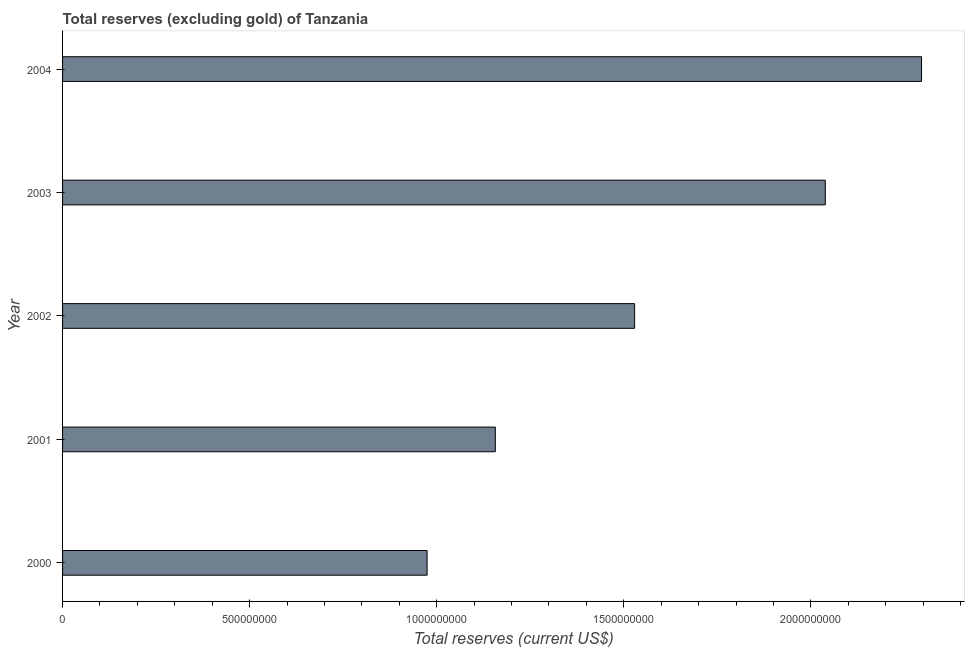What is the title of the graph?
Give a very brief answer. Total reserves (excluding gold) of Tanzania. What is the label or title of the X-axis?
Ensure brevity in your answer.  Total reserves (current US$). What is the label or title of the Y-axis?
Give a very brief answer. Year. What is the total reserves (excluding gold) in 2001?
Make the answer very short. 1.16e+09. Across all years, what is the maximum total reserves (excluding gold)?
Make the answer very short. 2.30e+09. Across all years, what is the minimum total reserves (excluding gold)?
Your answer should be compact. 9.74e+08. In which year was the total reserves (excluding gold) maximum?
Provide a succinct answer. 2004. What is the sum of the total reserves (excluding gold)?
Give a very brief answer. 7.99e+09. What is the difference between the total reserves (excluding gold) in 2001 and 2002?
Provide a short and direct response. -3.72e+08. What is the average total reserves (excluding gold) per year?
Offer a terse response. 1.60e+09. What is the median total reserves (excluding gold)?
Your answer should be very brief. 1.53e+09. In how many years, is the total reserves (excluding gold) greater than 600000000 US$?
Make the answer very short. 5. Do a majority of the years between 2003 and 2004 (inclusive) have total reserves (excluding gold) greater than 500000000 US$?
Provide a short and direct response. Yes. What is the ratio of the total reserves (excluding gold) in 2000 to that in 2001?
Ensure brevity in your answer.  0.84. Is the difference between the total reserves (excluding gold) in 2003 and 2004 greater than the difference between any two years?
Offer a very short reply. No. What is the difference between the highest and the second highest total reserves (excluding gold)?
Provide a succinct answer. 2.57e+08. Is the sum of the total reserves (excluding gold) in 2001 and 2002 greater than the maximum total reserves (excluding gold) across all years?
Your response must be concise. Yes. What is the difference between the highest and the lowest total reserves (excluding gold)?
Provide a succinct answer. 1.32e+09. In how many years, is the total reserves (excluding gold) greater than the average total reserves (excluding gold) taken over all years?
Offer a terse response. 2. What is the difference between two consecutive major ticks on the X-axis?
Provide a succinct answer. 5.00e+08. Are the values on the major ticks of X-axis written in scientific E-notation?
Your response must be concise. No. What is the Total reserves (current US$) in 2000?
Provide a succinct answer. 9.74e+08. What is the Total reserves (current US$) of 2001?
Your answer should be compact. 1.16e+09. What is the Total reserves (current US$) of 2002?
Ensure brevity in your answer.  1.53e+09. What is the Total reserves (current US$) in 2003?
Give a very brief answer. 2.04e+09. What is the Total reserves (current US$) of 2004?
Your answer should be compact. 2.30e+09. What is the difference between the Total reserves (current US$) in 2000 and 2001?
Your answer should be compact. -1.82e+08. What is the difference between the Total reserves (current US$) in 2000 and 2002?
Make the answer very short. -5.55e+08. What is the difference between the Total reserves (current US$) in 2000 and 2003?
Make the answer very short. -1.06e+09. What is the difference between the Total reserves (current US$) in 2000 and 2004?
Make the answer very short. -1.32e+09. What is the difference between the Total reserves (current US$) in 2001 and 2002?
Ensure brevity in your answer.  -3.72e+08. What is the difference between the Total reserves (current US$) in 2001 and 2003?
Provide a short and direct response. -8.82e+08. What is the difference between the Total reserves (current US$) in 2001 and 2004?
Your response must be concise. -1.14e+09. What is the difference between the Total reserves (current US$) in 2002 and 2003?
Keep it short and to the point. -5.10e+08. What is the difference between the Total reserves (current US$) in 2002 and 2004?
Make the answer very short. -7.67e+08. What is the difference between the Total reserves (current US$) in 2003 and 2004?
Offer a terse response. -2.57e+08. What is the ratio of the Total reserves (current US$) in 2000 to that in 2001?
Provide a succinct answer. 0.84. What is the ratio of the Total reserves (current US$) in 2000 to that in 2002?
Your answer should be compact. 0.64. What is the ratio of the Total reserves (current US$) in 2000 to that in 2003?
Offer a very short reply. 0.48. What is the ratio of the Total reserves (current US$) in 2000 to that in 2004?
Offer a very short reply. 0.42. What is the ratio of the Total reserves (current US$) in 2001 to that in 2002?
Keep it short and to the point. 0.76. What is the ratio of the Total reserves (current US$) in 2001 to that in 2003?
Make the answer very short. 0.57. What is the ratio of the Total reserves (current US$) in 2001 to that in 2004?
Your answer should be very brief. 0.5. What is the ratio of the Total reserves (current US$) in 2002 to that in 2003?
Ensure brevity in your answer.  0.75. What is the ratio of the Total reserves (current US$) in 2002 to that in 2004?
Ensure brevity in your answer.  0.67. What is the ratio of the Total reserves (current US$) in 2003 to that in 2004?
Your response must be concise. 0.89. 